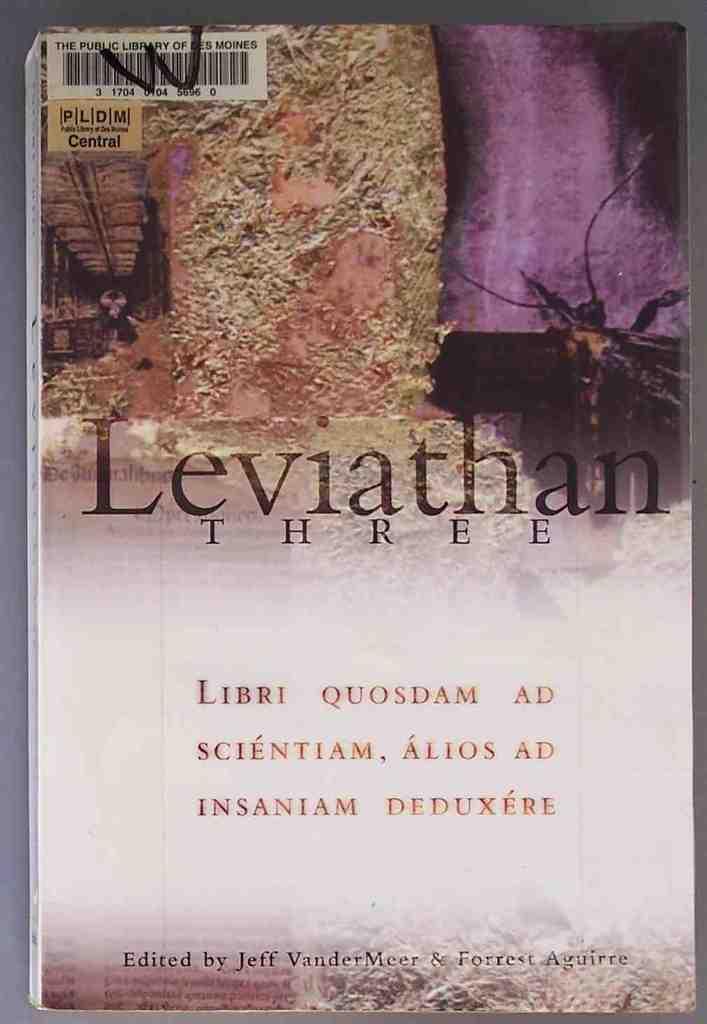What is the number?
Your response must be concise. Three. 